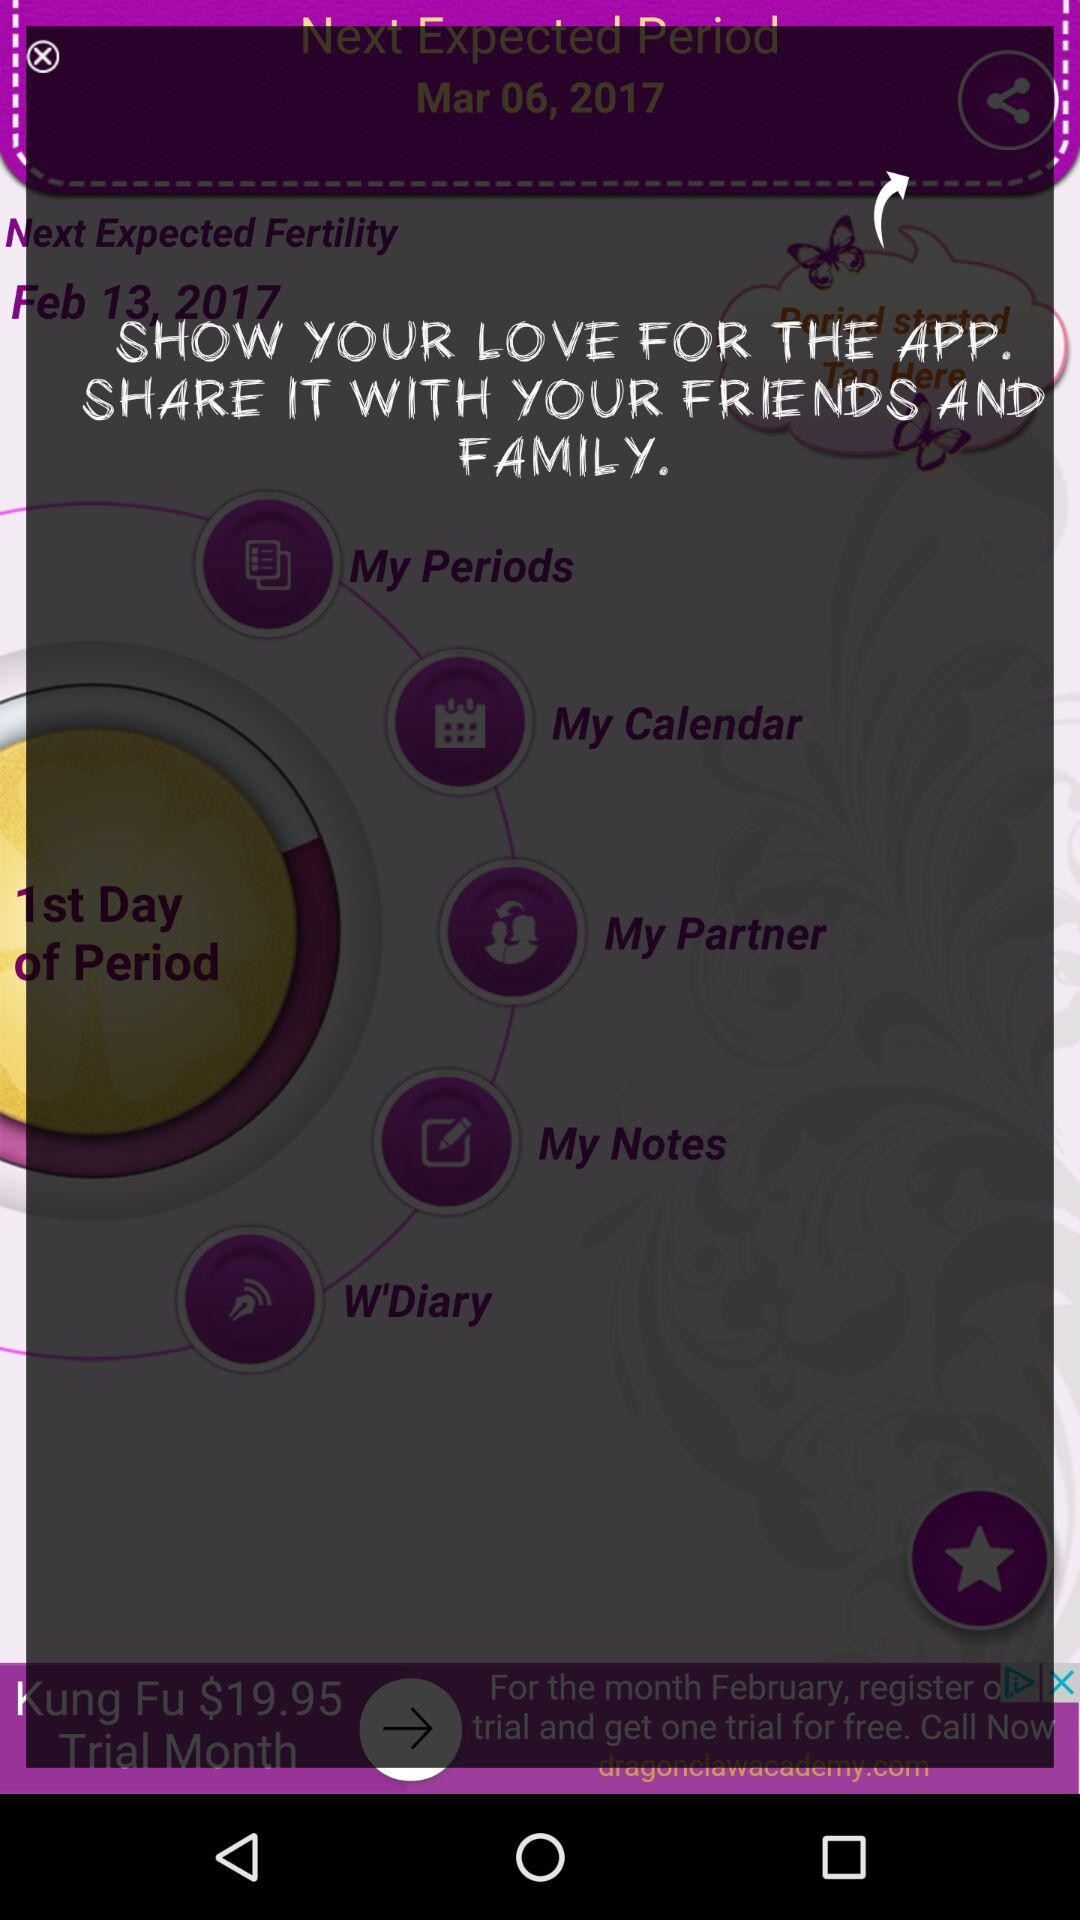What is the given date for the next expected period? The given date is March 06, 2017. 